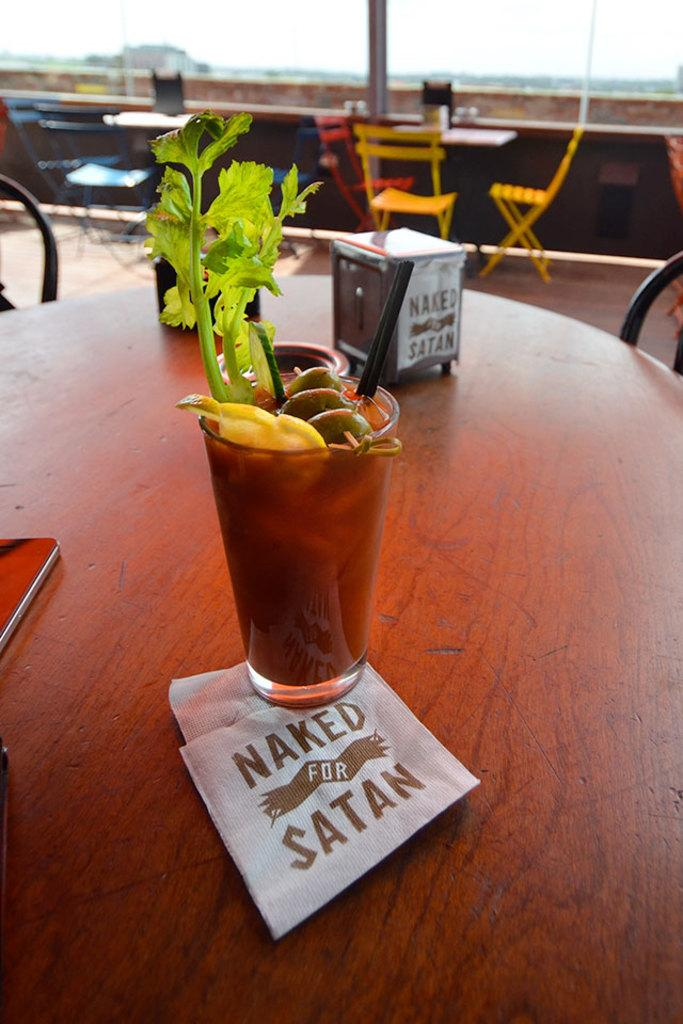What type of furniture is present in the image? There is a table in the image. How are the chairs arranged in relation to the table? Chairs are arranged around the table. What can be found on the table besides chairs? There are potted plants and papers on the table. Where is the brother sitting in the image? There is no brother present in the image. What type of tool is used to rake leaves in the image? There is no rake or leaves present in the image. 